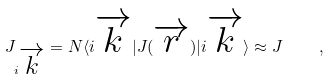Convert formula to latex. <formula><loc_0><loc_0><loc_500><loc_500>J _ { i \overrightarrow { k } } = N \langle i \overrightarrow { k } | J ( \overrightarrow { r } ) | i \overrightarrow { k } \rangle \approx J \quad ,</formula> 